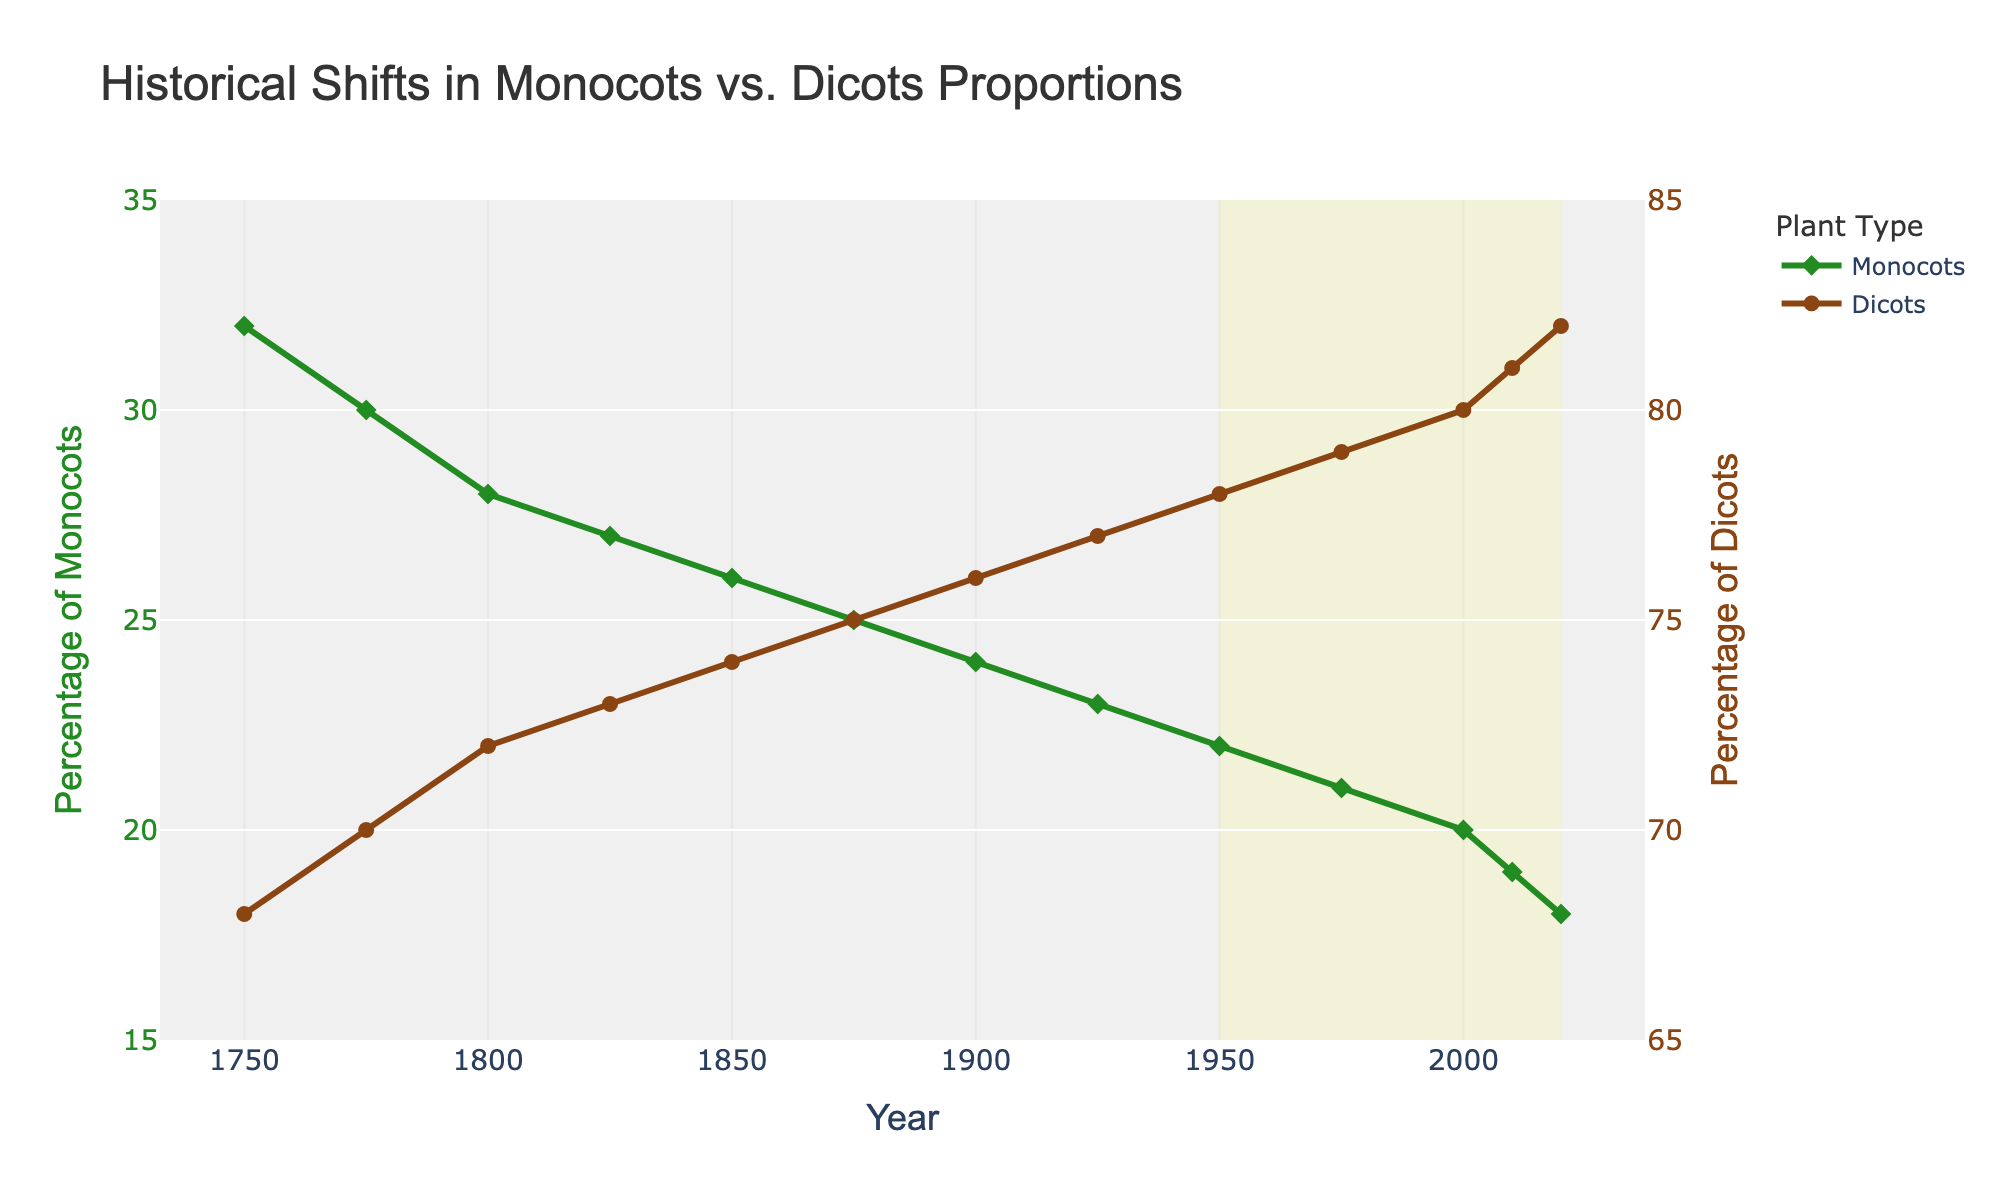What is the percentage of dicots in 1925? The percentage of dicots in 1925 can be found by looking at the point corresponding to the year 1925 on the dicots line (brown line).
Answer: 77 How does the percentage of monocots change from 1750 to 2020? To find this, subtract the percentage of monocots in 2020 from the percentage in 1750. So, 32% in 1750 and 18% in 2020 leads to a change of 32 - 18.
Answer: Decreases by 14% What is the trend observed in the proportions of monocots and dicots over time? By observing the lines, the percentage of monocots consistently decreases, while the percentage of dicots consistently increases from 1750 to 2020.
Answer: Monocots decrease, dicots increase In the year 2000, which group had a higher percentage, monocots or dicots? By looking at the values corresponding to the year 2000, we see the percentage of monocots is 20% and the percentage of dicots is 80%.
Answer: Dicots What is the difference between the percentages of dicots and monocots in 2020? Subtract the percentage of monocots in 2020 from the percentage of dicots in 2020. So, 82% (dicots) - 18% (monocots).
Answer: 64% In which year did monocots have the lowest recorded percentage? By finding the minimum value on the monocots line (green line), the lowest percentage can be found at the year 2020.
Answer: 2020 How has the difference between the percentages of dicots and monocots changed from 1950 to 2020? First, find the difference in 1950 (78% dicots - 22% monocots = 56%), and then in 2020 (82% dicots - 18% monocots = 64%). Next, subtract the difference in 1950 from the difference in 2020 (64% - 56%).
Answer: Increased by 8% What visual element highlights the modern era in the chart? The visual highlighting the modern era is a light yellow rectangle spanning from 1950 to 2020.
Answer: Light yellow rectangle During which time period does the annotation for "Modern Era" appear? The "Modern Era" annotation appears between the years 1950 and 2020, as indicated by the highlighted rectangle.
Answer: 1950-2020 